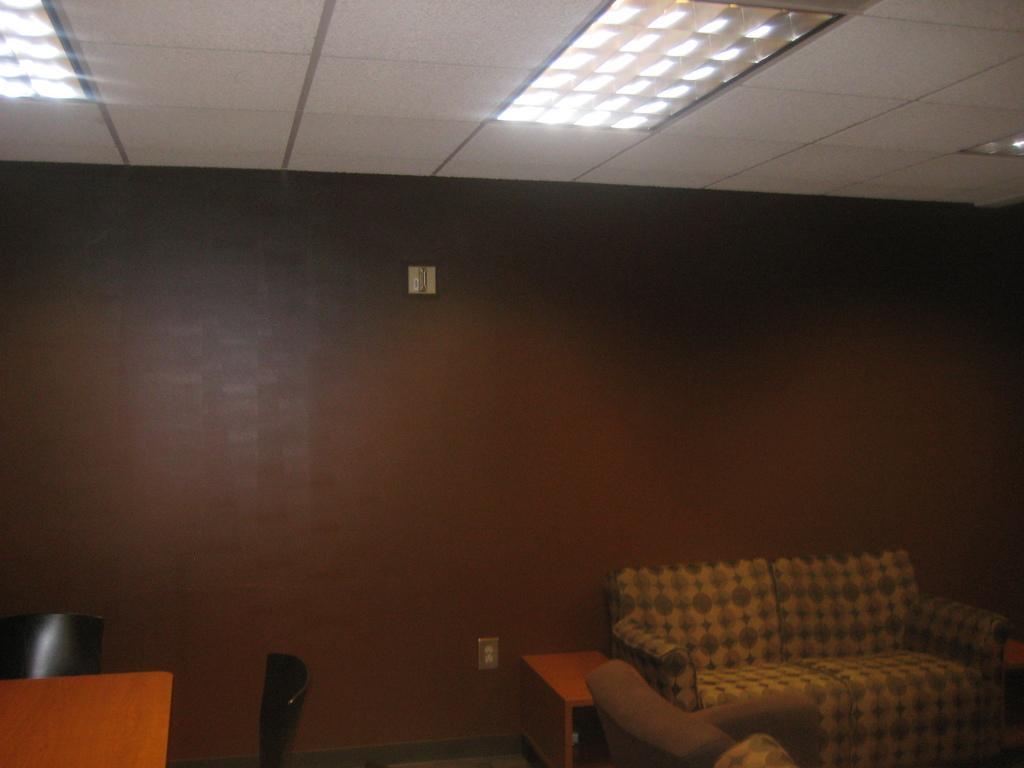Describe this image in one or two sentences. This is an image clicked inside the room. On the right side there is a couch and a small table. On the top I can see the lights. In the background there is a wall painted with a brown color. On the left side there is a table and two chairs are placed beside the table. 